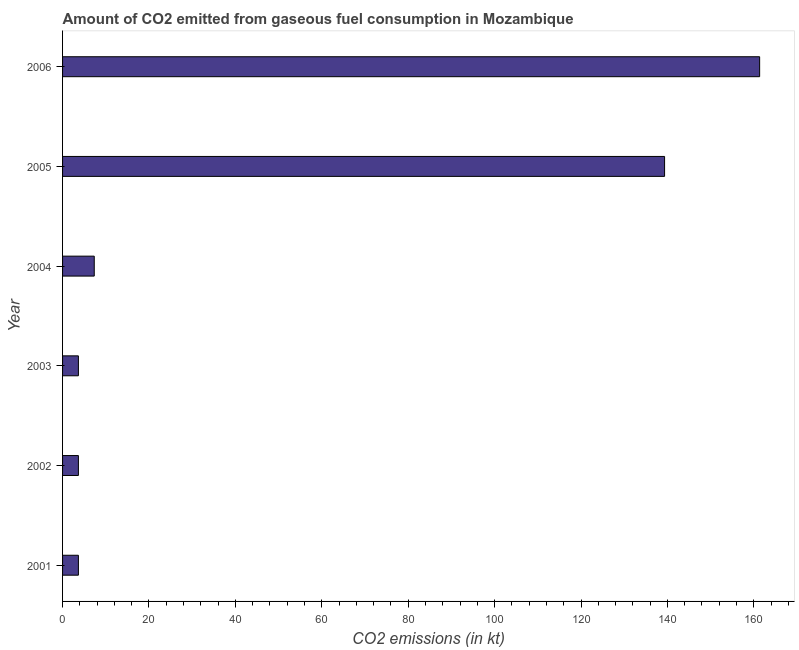Does the graph contain any zero values?
Provide a succinct answer. No. What is the title of the graph?
Your answer should be compact. Amount of CO2 emitted from gaseous fuel consumption in Mozambique. What is the label or title of the X-axis?
Offer a terse response. CO2 emissions (in kt). What is the label or title of the Y-axis?
Ensure brevity in your answer.  Year. What is the co2 emissions from gaseous fuel consumption in 2002?
Provide a succinct answer. 3.67. Across all years, what is the maximum co2 emissions from gaseous fuel consumption?
Your answer should be very brief. 161.35. Across all years, what is the minimum co2 emissions from gaseous fuel consumption?
Keep it short and to the point. 3.67. In which year was the co2 emissions from gaseous fuel consumption maximum?
Make the answer very short. 2006. In which year was the co2 emissions from gaseous fuel consumption minimum?
Offer a very short reply. 2001. What is the sum of the co2 emissions from gaseous fuel consumption?
Your response must be concise. 319.03. What is the difference between the co2 emissions from gaseous fuel consumption in 2001 and 2004?
Your response must be concise. -3.67. What is the average co2 emissions from gaseous fuel consumption per year?
Keep it short and to the point. 53.17. What is the median co2 emissions from gaseous fuel consumption?
Ensure brevity in your answer.  5.5. What is the ratio of the co2 emissions from gaseous fuel consumption in 2001 to that in 2005?
Make the answer very short. 0.03. What is the difference between the highest and the second highest co2 emissions from gaseous fuel consumption?
Offer a terse response. 22. What is the difference between the highest and the lowest co2 emissions from gaseous fuel consumption?
Keep it short and to the point. 157.68. How many bars are there?
Provide a succinct answer. 6. Are all the bars in the graph horizontal?
Offer a terse response. Yes. What is the difference between two consecutive major ticks on the X-axis?
Your answer should be very brief. 20. What is the CO2 emissions (in kt) in 2001?
Keep it short and to the point. 3.67. What is the CO2 emissions (in kt) of 2002?
Provide a short and direct response. 3.67. What is the CO2 emissions (in kt) of 2003?
Give a very brief answer. 3.67. What is the CO2 emissions (in kt) of 2004?
Provide a succinct answer. 7.33. What is the CO2 emissions (in kt) in 2005?
Your response must be concise. 139.35. What is the CO2 emissions (in kt) of 2006?
Ensure brevity in your answer.  161.35. What is the difference between the CO2 emissions (in kt) in 2001 and 2003?
Offer a very short reply. 0. What is the difference between the CO2 emissions (in kt) in 2001 and 2004?
Keep it short and to the point. -3.67. What is the difference between the CO2 emissions (in kt) in 2001 and 2005?
Provide a succinct answer. -135.68. What is the difference between the CO2 emissions (in kt) in 2001 and 2006?
Offer a very short reply. -157.68. What is the difference between the CO2 emissions (in kt) in 2002 and 2004?
Offer a very short reply. -3.67. What is the difference between the CO2 emissions (in kt) in 2002 and 2005?
Ensure brevity in your answer.  -135.68. What is the difference between the CO2 emissions (in kt) in 2002 and 2006?
Offer a terse response. -157.68. What is the difference between the CO2 emissions (in kt) in 2003 and 2004?
Your response must be concise. -3.67. What is the difference between the CO2 emissions (in kt) in 2003 and 2005?
Provide a short and direct response. -135.68. What is the difference between the CO2 emissions (in kt) in 2003 and 2006?
Provide a short and direct response. -157.68. What is the difference between the CO2 emissions (in kt) in 2004 and 2005?
Your response must be concise. -132.01. What is the difference between the CO2 emissions (in kt) in 2004 and 2006?
Give a very brief answer. -154.01. What is the difference between the CO2 emissions (in kt) in 2005 and 2006?
Give a very brief answer. -22. What is the ratio of the CO2 emissions (in kt) in 2001 to that in 2003?
Keep it short and to the point. 1. What is the ratio of the CO2 emissions (in kt) in 2001 to that in 2004?
Ensure brevity in your answer.  0.5. What is the ratio of the CO2 emissions (in kt) in 2001 to that in 2005?
Provide a succinct answer. 0.03. What is the ratio of the CO2 emissions (in kt) in 2001 to that in 2006?
Give a very brief answer. 0.02. What is the ratio of the CO2 emissions (in kt) in 2002 to that in 2003?
Provide a succinct answer. 1. What is the ratio of the CO2 emissions (in kt) in 2002 to that in 2004?
Give a very brief answer. 0.5. What is the ratio of the CO2 emissions (in kt) in 2002 to that in 2005?
Keep it short and to the point. 0.03. What is the ratio of the CO2 emissions (in kt) in 2002 to that in 2006?
Your answer should be very brief. 0.02. What is the ratio of the CO2 emissions (in kt) in 2003 to that in 2004?
Give a very brief answer. 0.5. What is the ratio of the CO2 emissions (in kt) in 2003 to that in 2005?
Offer a very short reply. 0.03. What is the ratio of the CO2 emissions (in kt) in 2003 to that in 2006?
Provide a succinct answer. 0.02. What is the ratio of the CO2 emissions (in kt) in 2004 to that in 2005?
Offer a terse response. 0.05. What is the ratio of the CO2 emissions (in kt) in 2004 to that in 2006?
Provide a succinct answer. 0.04. What is the ratio of the CO2 emissions (in kt) in 2005 to that in 2006?
Keep it short and to the point. 0.86. 